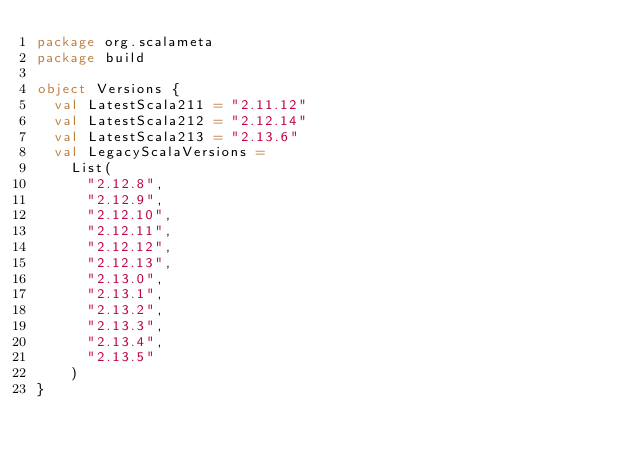Convert code to text. <code><loc_0><loc_0><loc_500><loc_500><_Scala_>package org.scalameta
package build

object Versions {
  val LatestScala211 = "2.11.12"
  val LatestScala212 = "2.12.14"
  val LatestScala213 = "2.13.6"
  val LegacyScalaVersions =
    List(
      "2.12.8",
      "2.12.9",
      "2.12.10",
      "2.12.11",
      "2.12.12",
      "2.12.13",
      "2.13.0",
      "2.13.1",
      "2.13.2",
      "2.13.3",
      "2.13.4",
      "2.13.5"
    )
}
</code> 